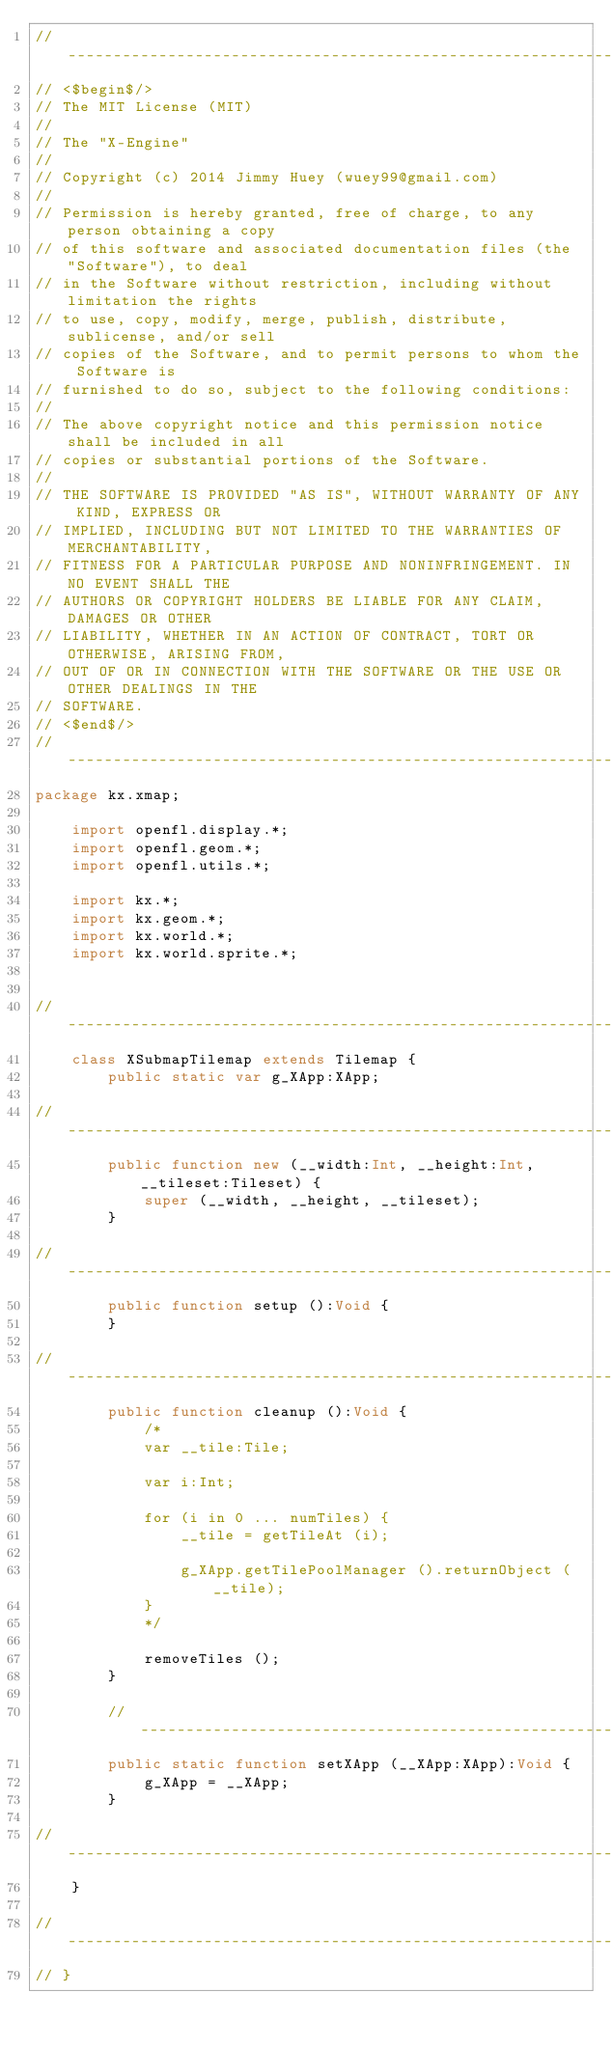Convert code to text. <code><loc_0><loc_0><loc_500><loc_500><_Haxe_>//------------------------------------------------------------------------------------------
// <$begin$/>
// The MIT License (MIT)
//
// The "X-Engine"
//
// Copyright (c) 2014 Jimmy Huey (wuey99@gmail.com)
//
// Permission is hereby granted, free of charge, to any person obtaining a copy
// of this software and associated documentation files (the "Software"), to deal
// in the Software without restriction, including without limitation the rights
// to use, copy, modify, merge, publish, distribute, sublicense, and/or sell
// copies of the Software, and to permit persons to whom the Software is
// furnished to do so, subject to the following conditions:
//
// The above copyright notice and this permission notice shall be included in all
// copies or substantial portions of the Software.
//
// THE SOFTWARE IS PROVIDED "AS IS", WITHOUT WARRANTY OF ANY KIND, EXPRESS OR
// IMPLIED, INCLUDING BUT NOT LIMITED TO THE WARRANTIES OF MERCHANTABILITY,
// FITNESS FOR A PARTICULAR PURPOSE AND NONINFRINGEMENT. IN NO EVENT SHALL THE
// AUTHORS OR COPYRIGHT HOLDERS BE LIABLE FOR ANY CLAIM, DAMAGES OR OTHER
// LIABILITY, WHETHER IN AN ACTION OF CONTRACT, TORT OR OTHERWISE, ARISING FROM,
// OUT OF OR IN CONNECTION WITH THE SOFTWARE OR THE USE OR OTHER DEALINGS IN THE
// SOFTWARE.
// <$end$/>
//------------------------------------------------------------------------------------------
package kx.xmap;

	import openfl.display.*;
	import openfl.geom.*;
	import openfl.utils.*;
	
	import kx.*;
	import kx.geom.*;
	import kx.world.*;
	import kx.world.sprite.*;
	
	
//------------------------------------------------------------------------------------------	
	class XSubmapTilemap extends Tilemap {
		public static var g_XApp:XApp;
		
//------------------------------------------------------------------------------------------
		public function new (__width:Int, __height:Int, __tileset:Tileset) {
			super (__width, __height, __tileset);
		}

//------------------------------------------------------------------------------------------
		public function setup ():Void {
		}
		
//------------------------------------------------------------------------------------------
		public function cleanup ():Void {
			/*
			var __tile:Tile;
			
			var i:Int;
			
			for (i in 0 ... numTiles) {
				__tile = getTileAt (i);
				
				g_XApp.getTilePoolManager ().returnObject (__tile);
			}
			*/
			
			removeTiles ();
		}
		
		//------------------------------------------------------------------------------------------
		public static function setXApp (__XApp:XApp):Void {
			g_XApp = __XApp;
		}
		
//------------------------------------------------------------------------------------------
	}
	
//------------------------------------------------------------------------------------------
// }
</code> 